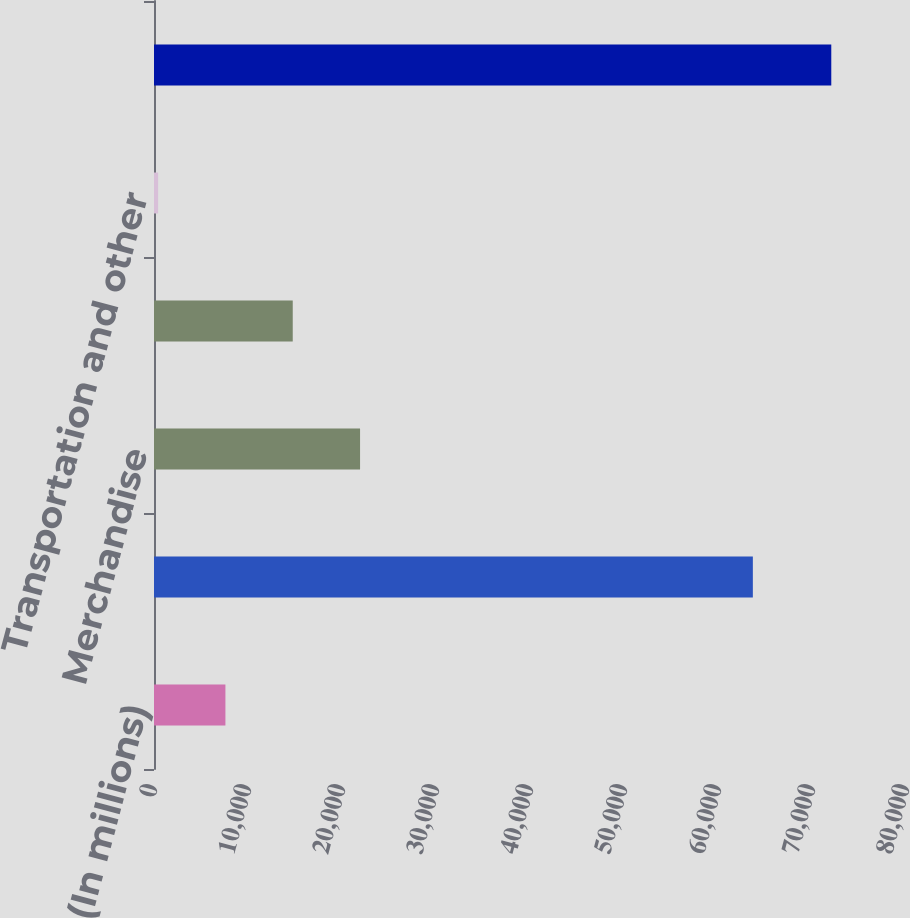Convert chart to OTSL. <chart><loc_0><loc_0><loc_500><loc_500><bar_chart><fcel>(In millions)<fcel>Refined products<fcel>Merchandise<fcel>Crude oil and refinery<fcel>Transportation and other<fcel>Sales and other operating<nl><fcel>7598.4<fcel>63708<fcel>21921.2<fcel>14759.8<fcel>437<fcel>72051<nl></chart> 